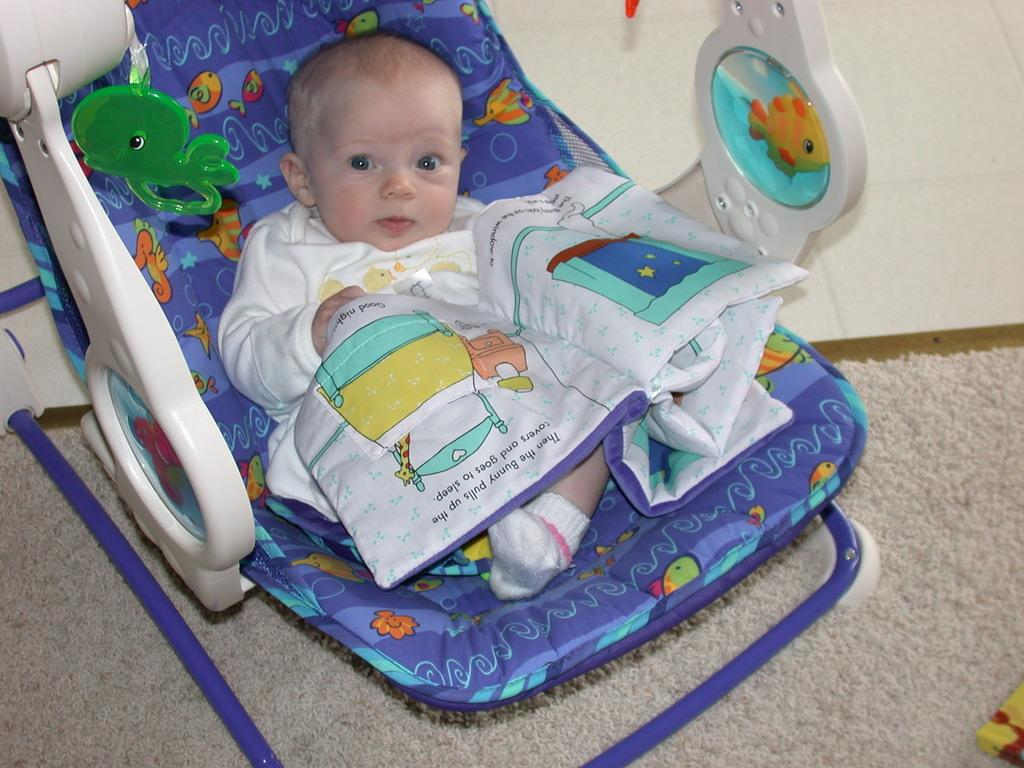What is the main subject of the image? The main subject of the image is a baby in a cradle. What is the baby lying on in the image? The baby is lying on a mat in the image. What type of humor does the governor display in the image? There is no governor present in the image, and therefore no humor can be observed. 